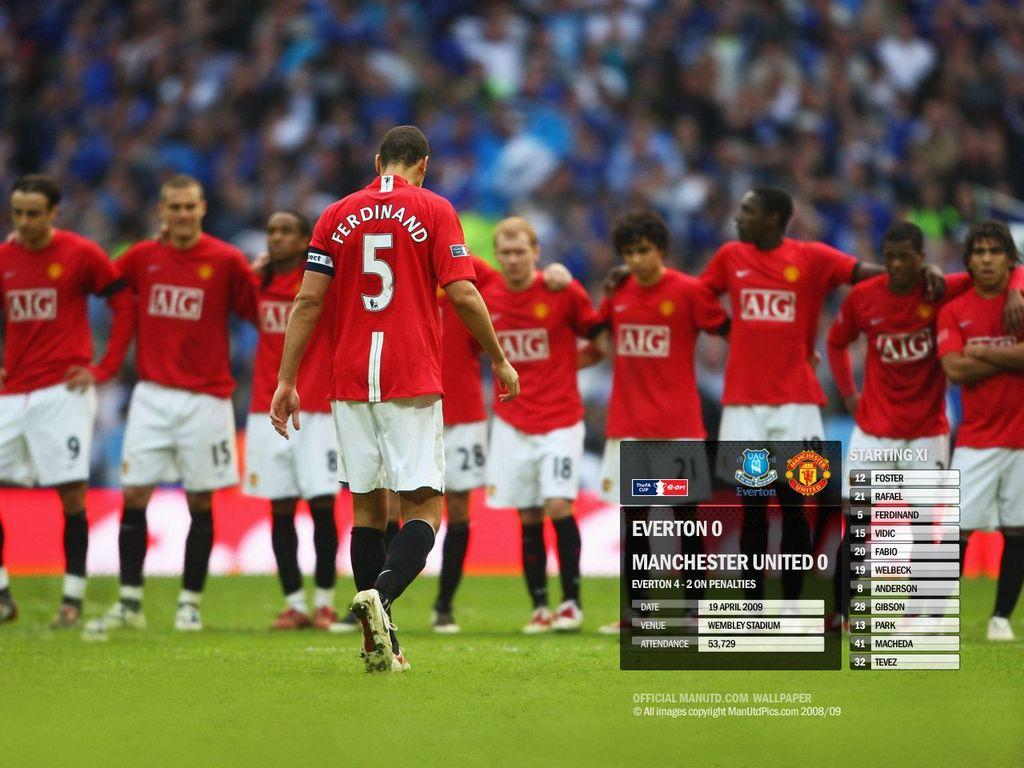<image>
Summarize the visual content of the image. A picture of a soccer team with an upcoming games date is being shown 